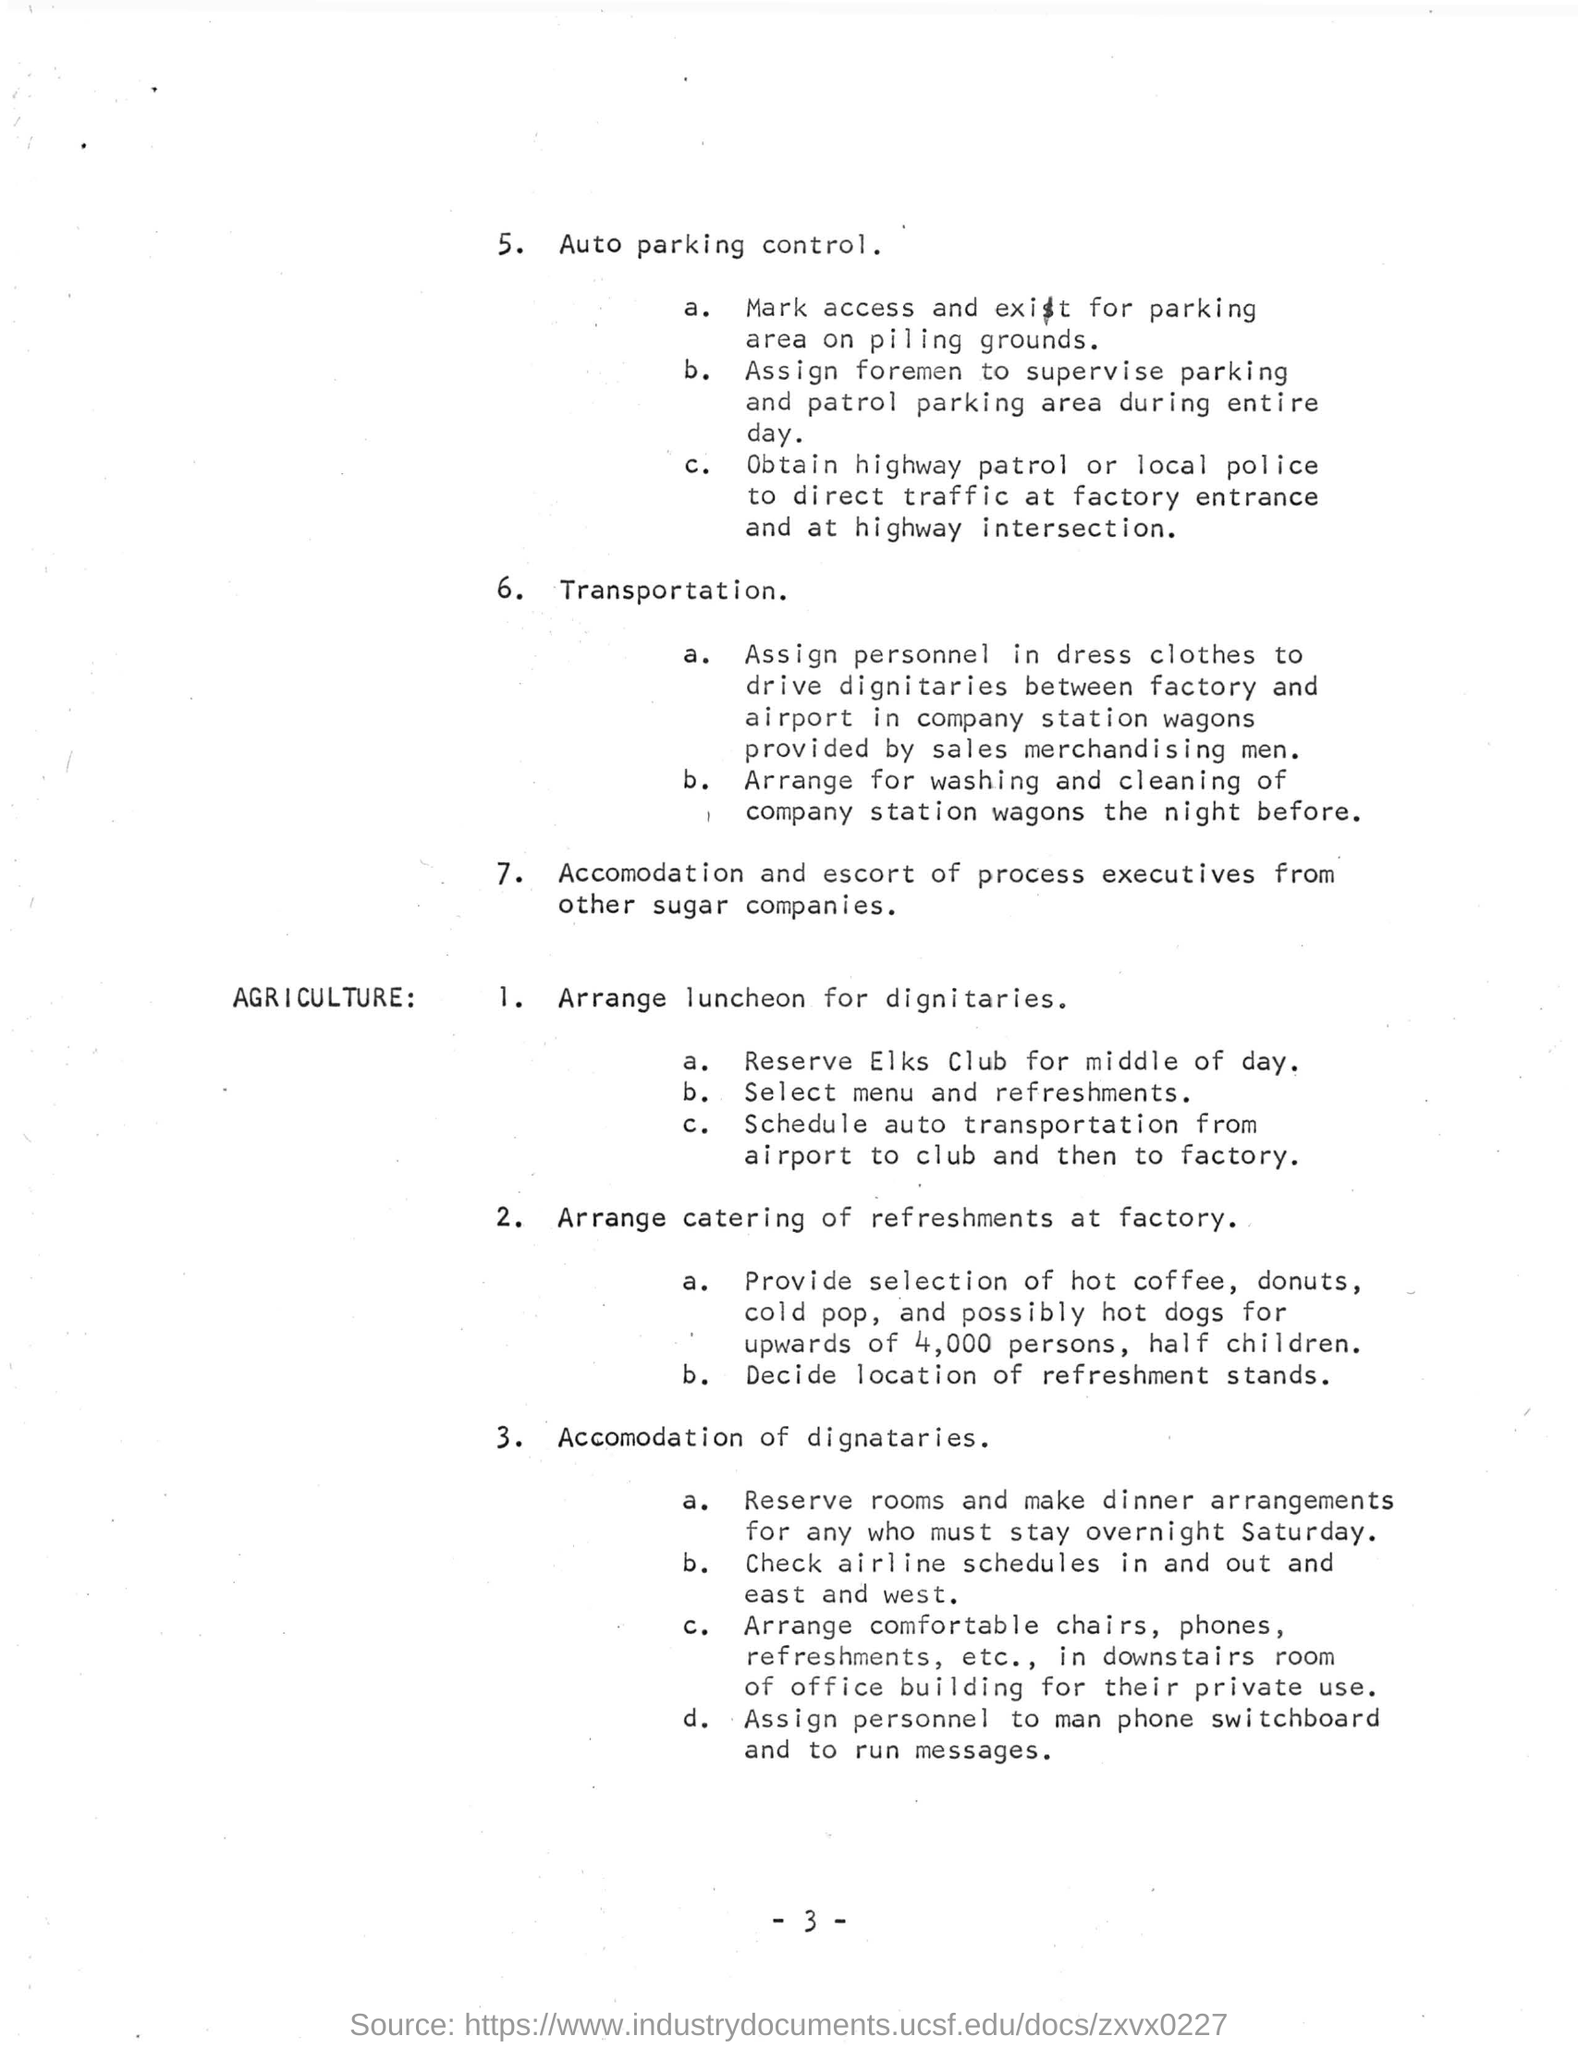Indicate a few pertinent items in this graphic. Transportation arrangements are made from the airport to the club and then to the factory for dignitaries. I declare that the accommodation and escort of process executives from various companies, including sugar companies, will be provided. 